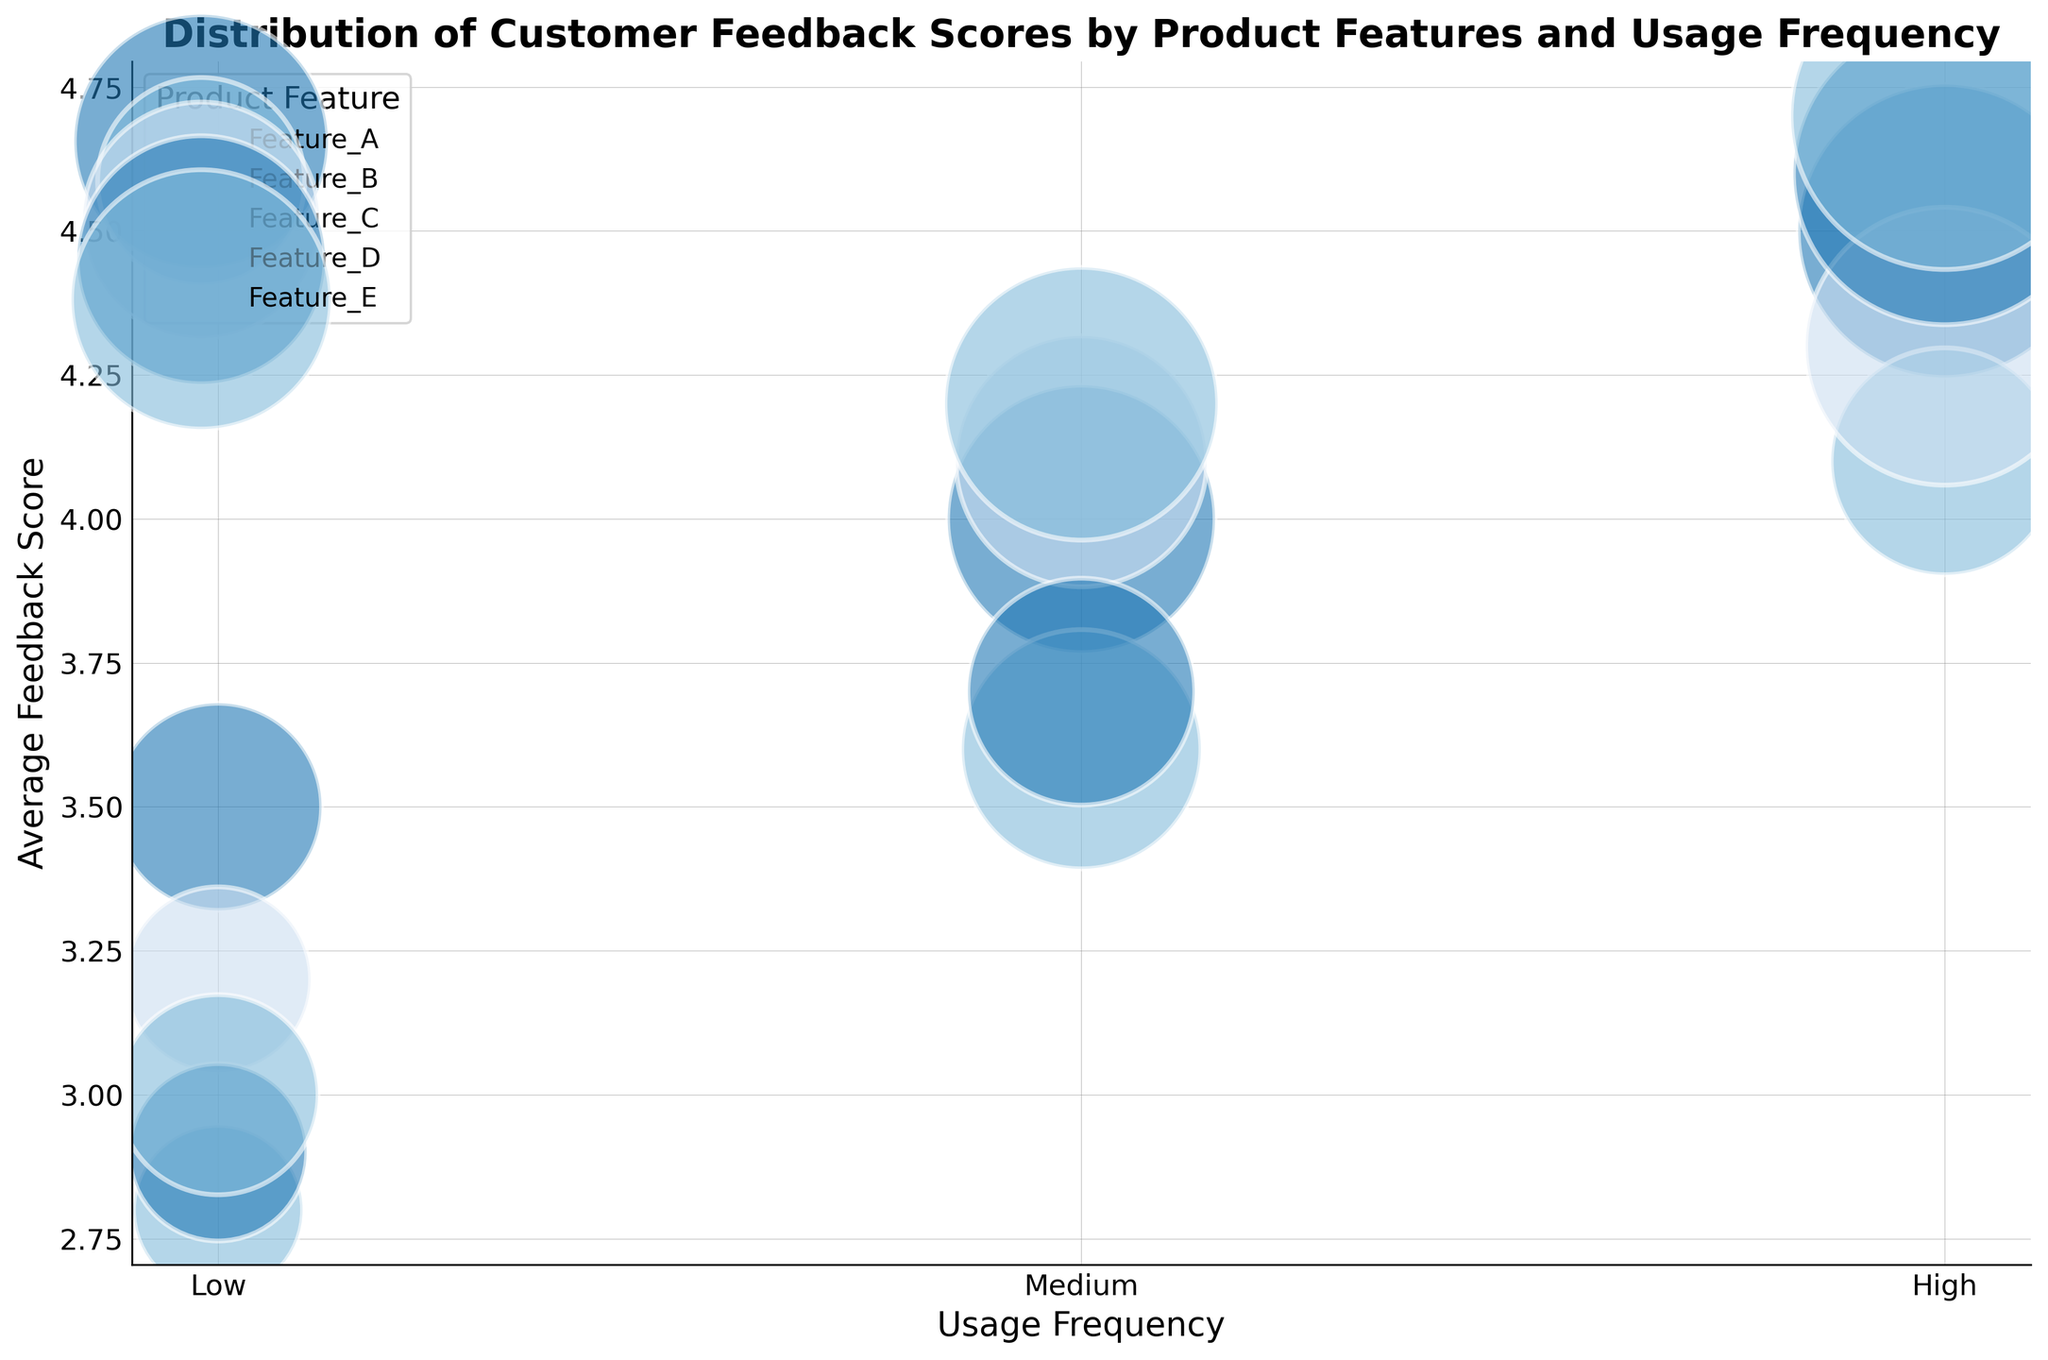What is the product feature with the highest average feedback score when usage frequency is high? Looking at the plot, for high usage frequency, check the y-axis values to find the highest average feedback score among all product features. Feature_E has the highest score of 4.7.
Answer: Feature_E Which product feature shows the largest bubble for medium usage frequency? At medium usage frequency, observe the size of each bubble, which represents the count of feedbacks. Feature_E has the largest bubble, indicating the highest count.
Answer: Feature_E What is the average feedback score for Feature_C when usage frequency is medium? Locate the medium column for Feature_C and read the y-axis value. For medium usage frequency, Feature_C has an average feedback score of 4.1.
Answer: 4.1 How does the feedback score of Feature_B compare between low and high usage frequencies? Identify the average feedback scores of Feature_B at low and high usage frequencies by observing the y-axis values. For low usage, the score is 2.8, and for high usage, it is 4.1. The high usage score is significantly greater.
Answer: Higher at high frequency Which product feature has the smallest bubble with low usage frequency, and what does this indicate? At low usage frequency, find the smallest bubble by comparing the sizes. Feature_B has the smallest bubble, indicating it has the lowest count of feedback reviews.
Answer: Feature_B What is the difference in average feedback score between Feature_A and Feature_D for high usage frequency? Subtract the average feedback score of Feature_D from Feature_A at high usage frequency. Feature_A's score is 4.5, and Feature_D's is 4.6, so the difference is 4.6 - 4.5 = 0.1.
Answer: 0.1 Which product feature exhibits the most consistent average feedback score across all usage frequencies? Identify which product feature has the smallest variation in y-axis values (feedback scores) across low, medium, and high usage frequencies. Feature_A shows a steady increase from low (3.5) to high (4.5), indicating consistency.
Answer: Feature_A At which usage frequency does Feature_C achieve an average feedback score higher than 4.0, and what is the exact score? Check Feature_C's average feedback scores at different usage frequencies. For high and medium usage frequencies, Feature_C achieves scores of 4.3 and 4.1 respectively.
Answer: Medium and High, 4.1 and 4.3 Which product feature and usage frequency combination has the maximum count of feedbacks? Identify the largest bubble in the entire chart, which represents the maximum count of feedbacks. Feature_E with high usage frequency appears as the largest bubble, indicating the highest count of 330.
Answer: Feature_E with High usage frequency 